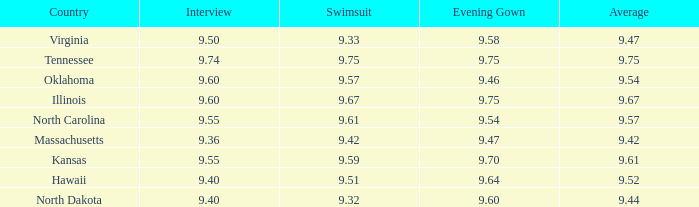What is the swimsuit score when the interview was 9.74? 9.75. 